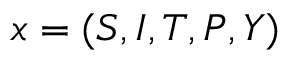Convert formula to latex. <formula><loc_0><loc_0><loc_500><loc_500>x = ( S , I , T , P , Y )</formula> 